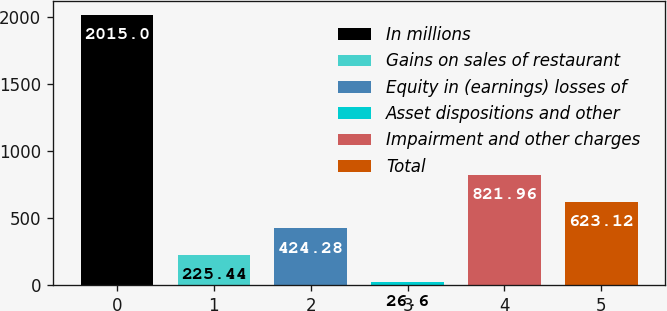Convert chart. <chart><loc_0><loc_0><loc_500><loc_500><bar_chart><fcel>In millions<fcel>Gains on sales of restaurant<fcel>Equity in (earnings) losses of<fcel>Asset dispositions and other<fcel>Impairment and other charges<fcel>Total<nl><fcel>2015<fcel>225.44<fcel>424.28<fcel>26.6<fcel>821.96<fcel>623.12<nl></chart> 